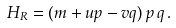Convert formula to latex. <formula><loc_0><loc_0><loc_500><loc_500>H _ { R } = ( m + u p - v q ) \, p \, q \, .</formula> 